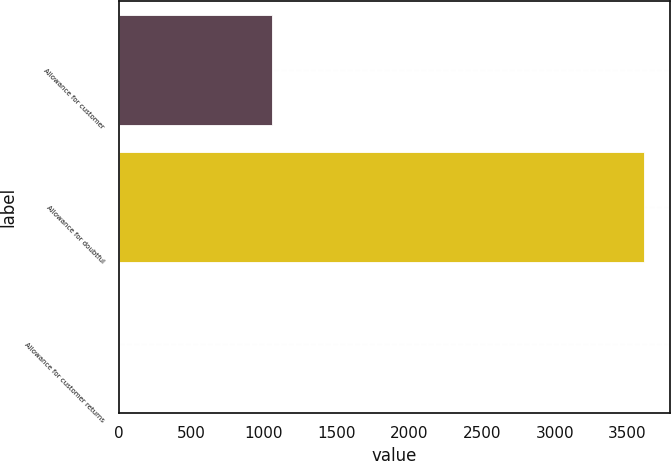Convert chart to OTSL. <chart><loc_0><loc_0><loc_500><loc_500><bar_chart><fcel>Allowance for customer<fcel>Allowance for doubtful<fcel>Allowance for customer returns<nl><fcel>1059<fcel>3613<fcel>5<nl></chart> 